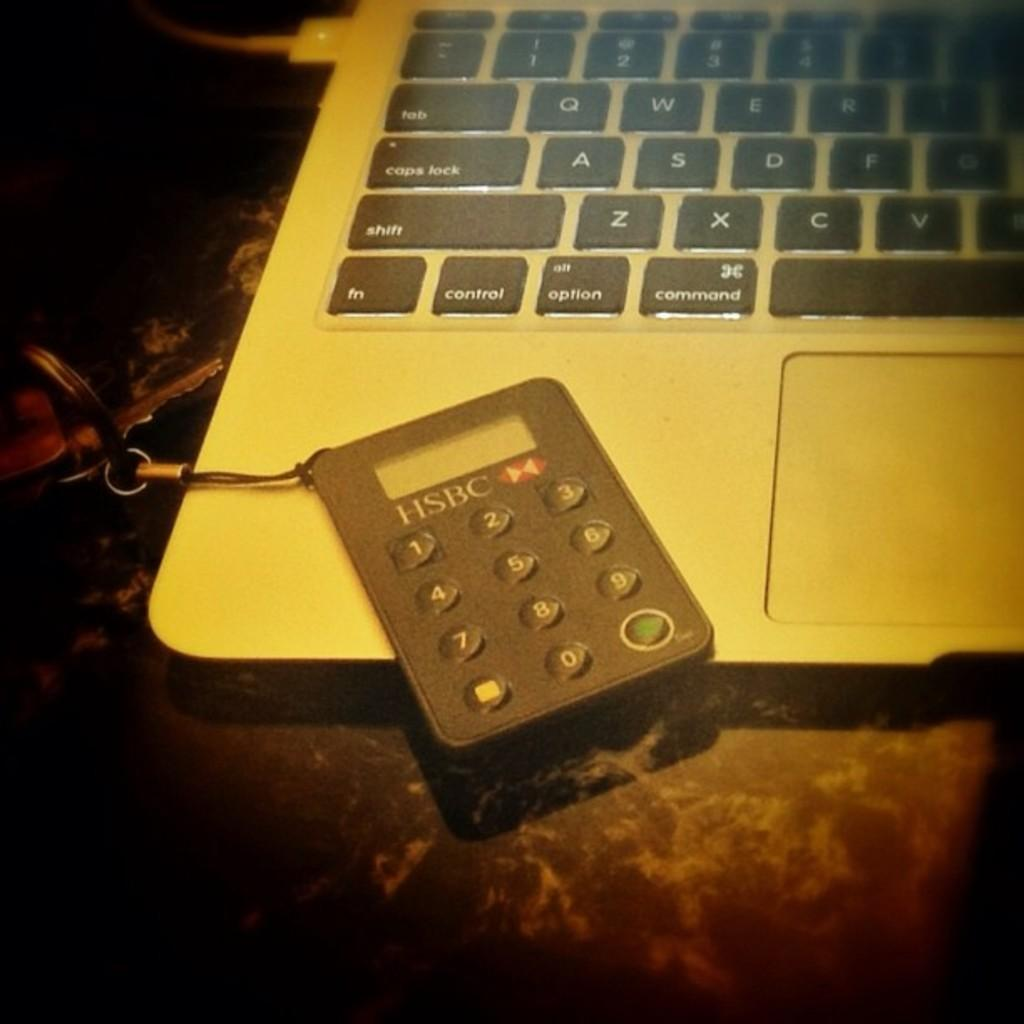<image>
Give a short and clear explanation of the subsequent image. A small calculator key chain from HSBC sits on top of a laptop computer 